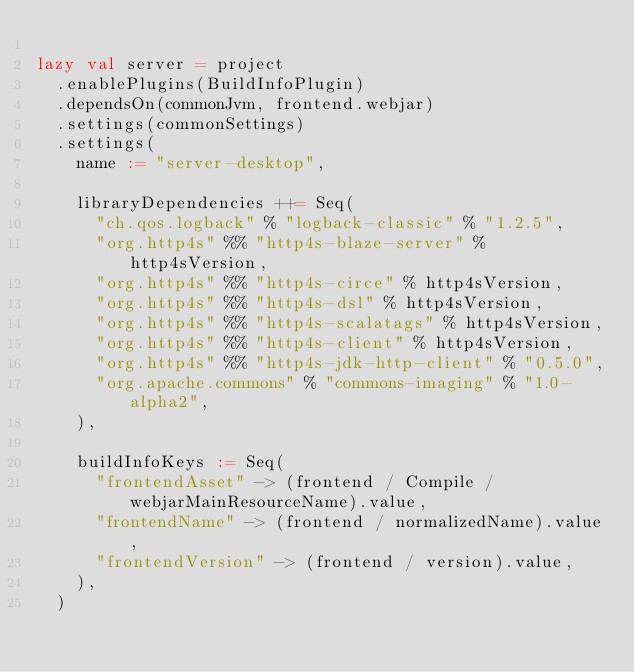Convert code to text. <code><loc_0><loc_0><loc_500><loc_500><_Scala_>
lazy val server = project
  .enablePlugins(BuildInfoPlugin)
  .dependsOn(commonJvm, frontend.webjar)
  .settings(commonSettings)
  .settings(
    name := "server-desktop",

    libraryDependencies ++= Seq(
      "ch.qos.logback" % "logback-classic" % "1.2.5",
      "org.http4s" %% "http4s-blaze-server" % http4sVersion,
      "org.http4s" %% "http4s-circe" % http4sVersion,
      "org.http4s" %% "http4s-dsl" % http4sVersion,
      "org.http4s" %% "http4s-scalatags" % http4sVersion,
      "org.http4s" %% "http4s-client" % http4sVersion,
      "org.http4s" %% "http4s-jdk-http-client" % "0.5.0",
      "org.apache.commons" % "commons-imaging" % "1.0-alpha2",
    ),

    buildInfoKeys := Seq(
      "frontendAsset" -> (frontend / Compile / webjarMainResourceName).value,
      "frontendName" -> (frontend / normalizedName).value,
      "frontendVersion" -> (frontend / version).value,
    ),
  )
</code> 